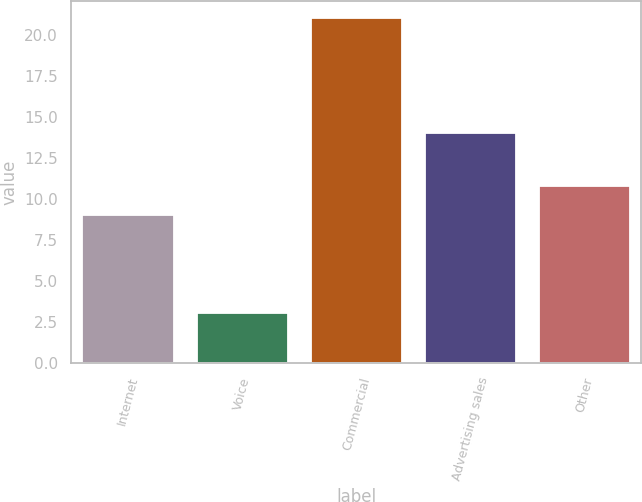Convert chart. <chart><loc_0><loc_0><loc_500><loc_500><bar_chart><fcel>Internet<fcel>Voice<fcel>Commercial<fcel>Advertising sales<fcel>Other<nl><fcel>9<fcel>3<fcel>21<fcel>14<fcel>10.8<nl></chart> 